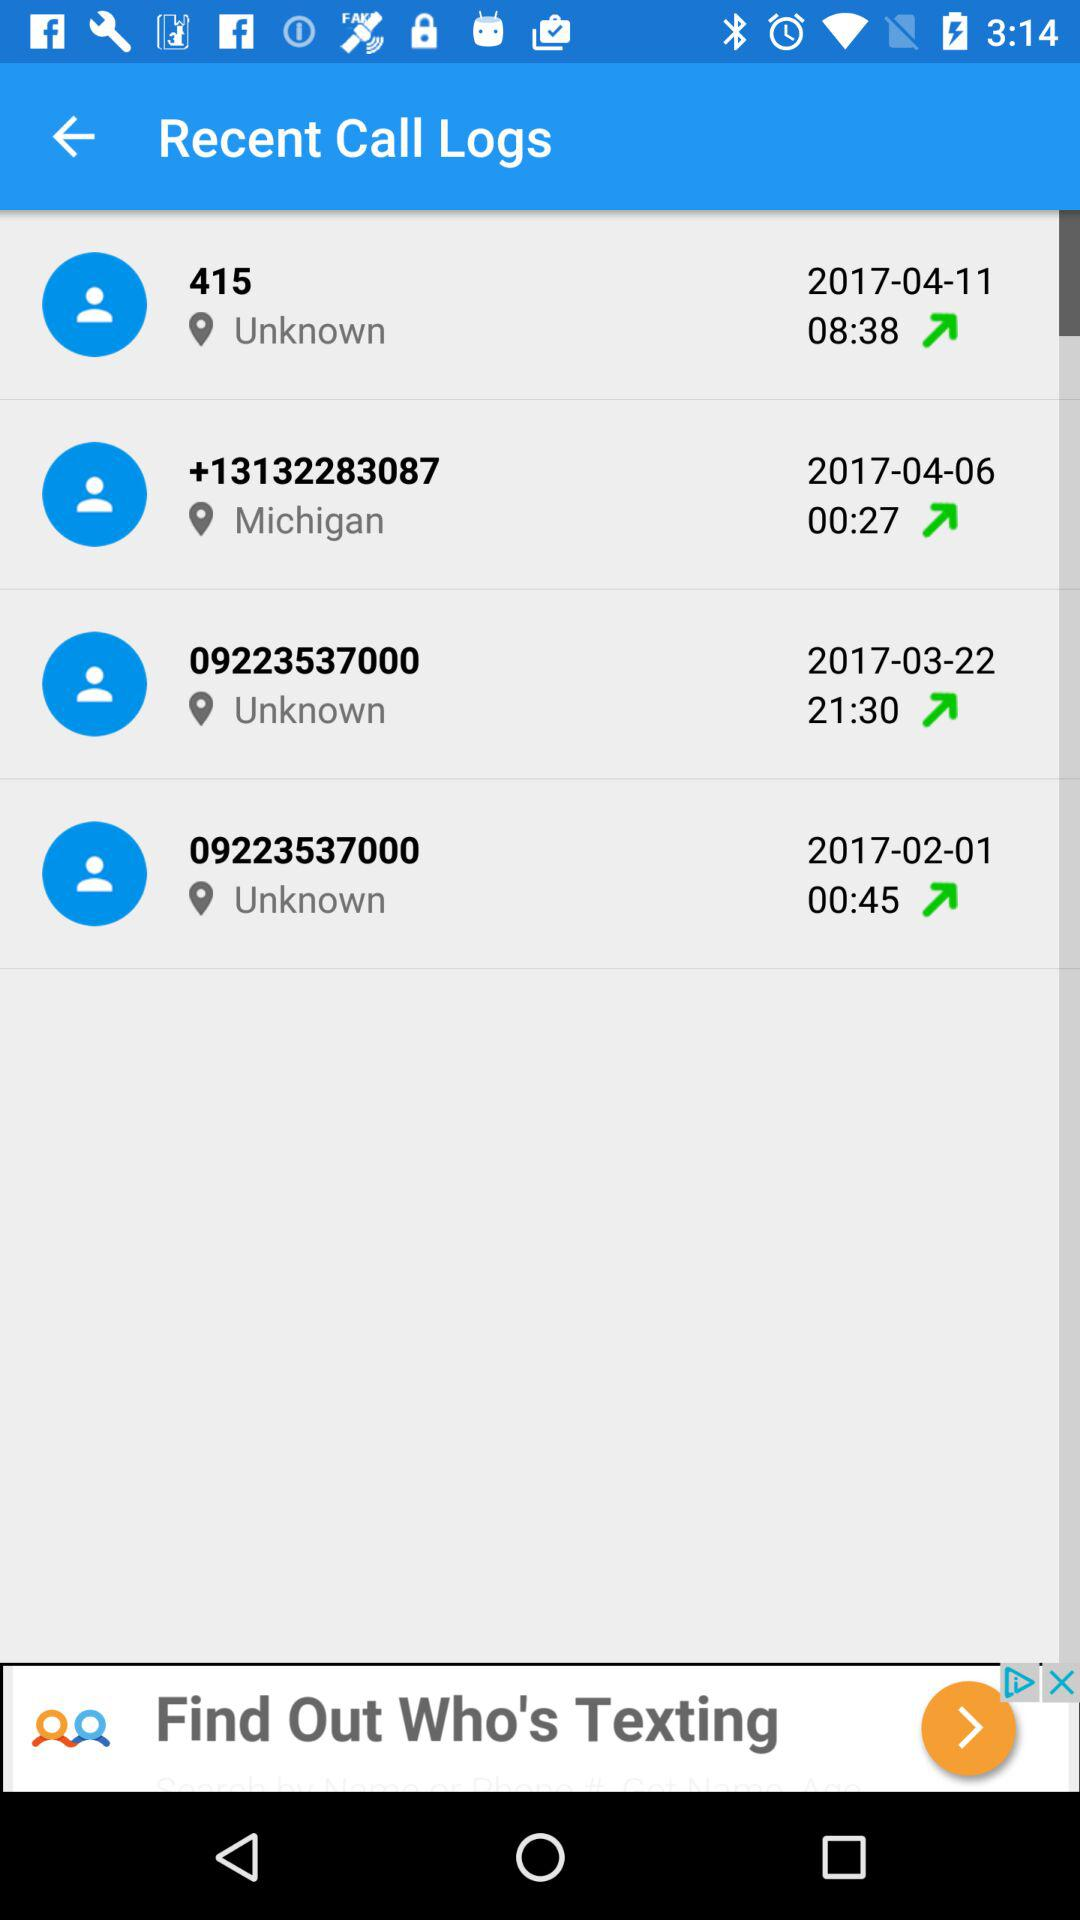How many calls were made in February?
Answer the question using a single word or phrase. 1 